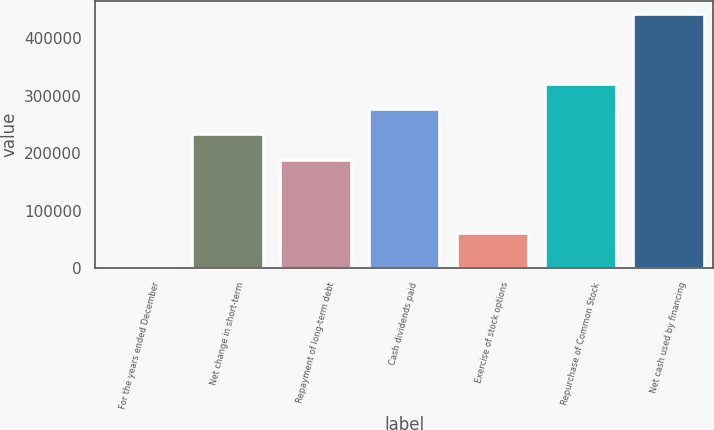Convert chart to OTSL. <chart><loc_0><loc_0><loc_500><loc_500><bar_chart><fcel>For the years ended December<fcel>Net change in short-term<fcel>Repayment of long-term debt<fcel>Cash dividends paid<fcel>Exercise of stock options<fcel>Repurchase of Common Stock<fcel>Net cash used by financing<nl><fcel>2007<fcel>232933<fcel>188891<fcel>276975<fcel>59958<fcel>321017<fcel>442426<nl></chart> 